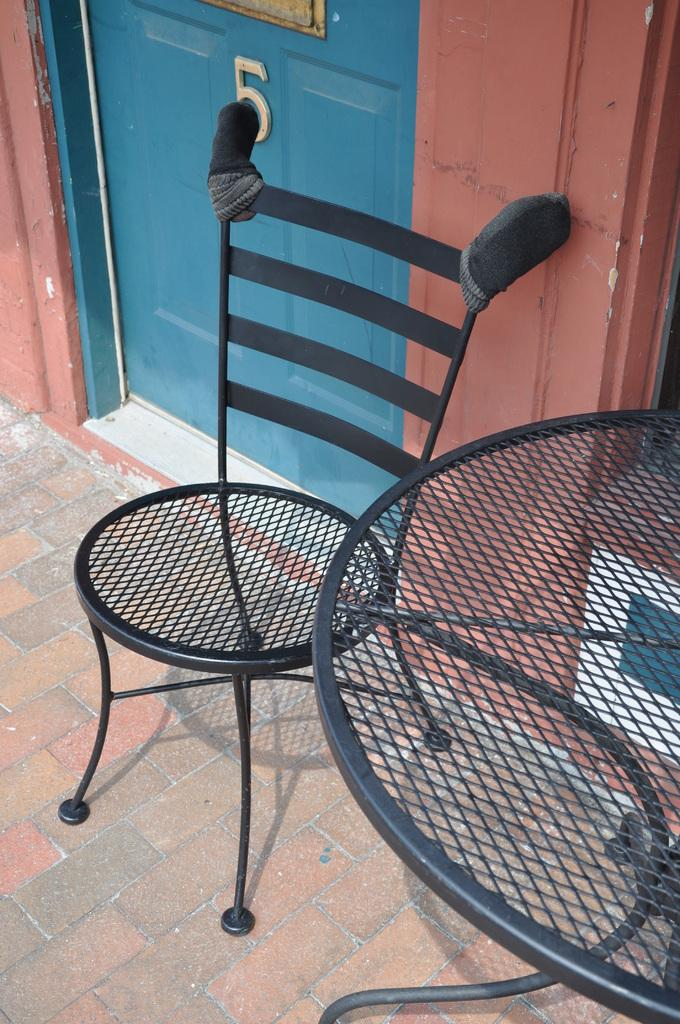What type of chair is in the image? There is a black color steel chair in the image. What type of table is in the image? There is a black color steel table in the image. What color is the door in the image? The door in the image is blue. What color is the wall in the image? The wall in the image is blue. How does the oil affect the bubble in the image? There is no oil or bubble present in the image. 